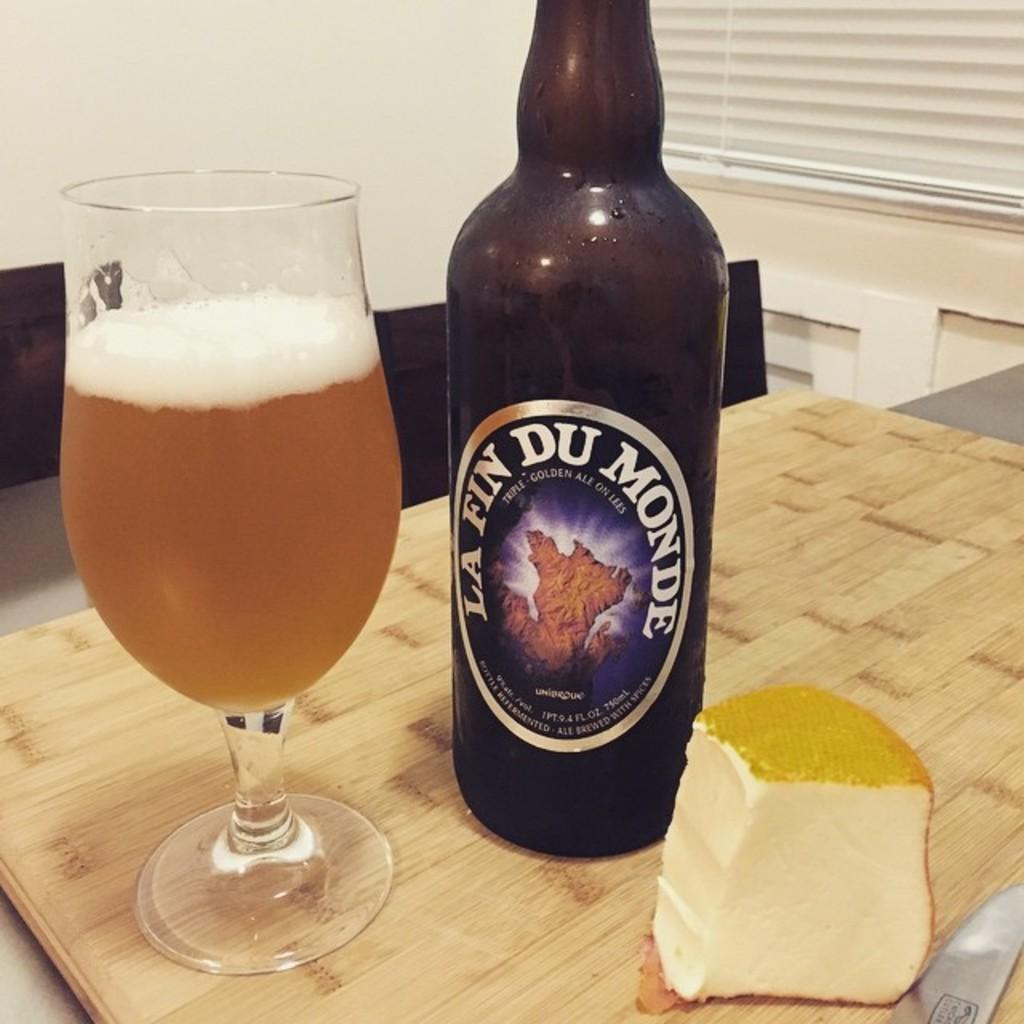<image>
Present a compact description of the photo's key features. A bottle of La Fin Monde next to cheese and a glass 